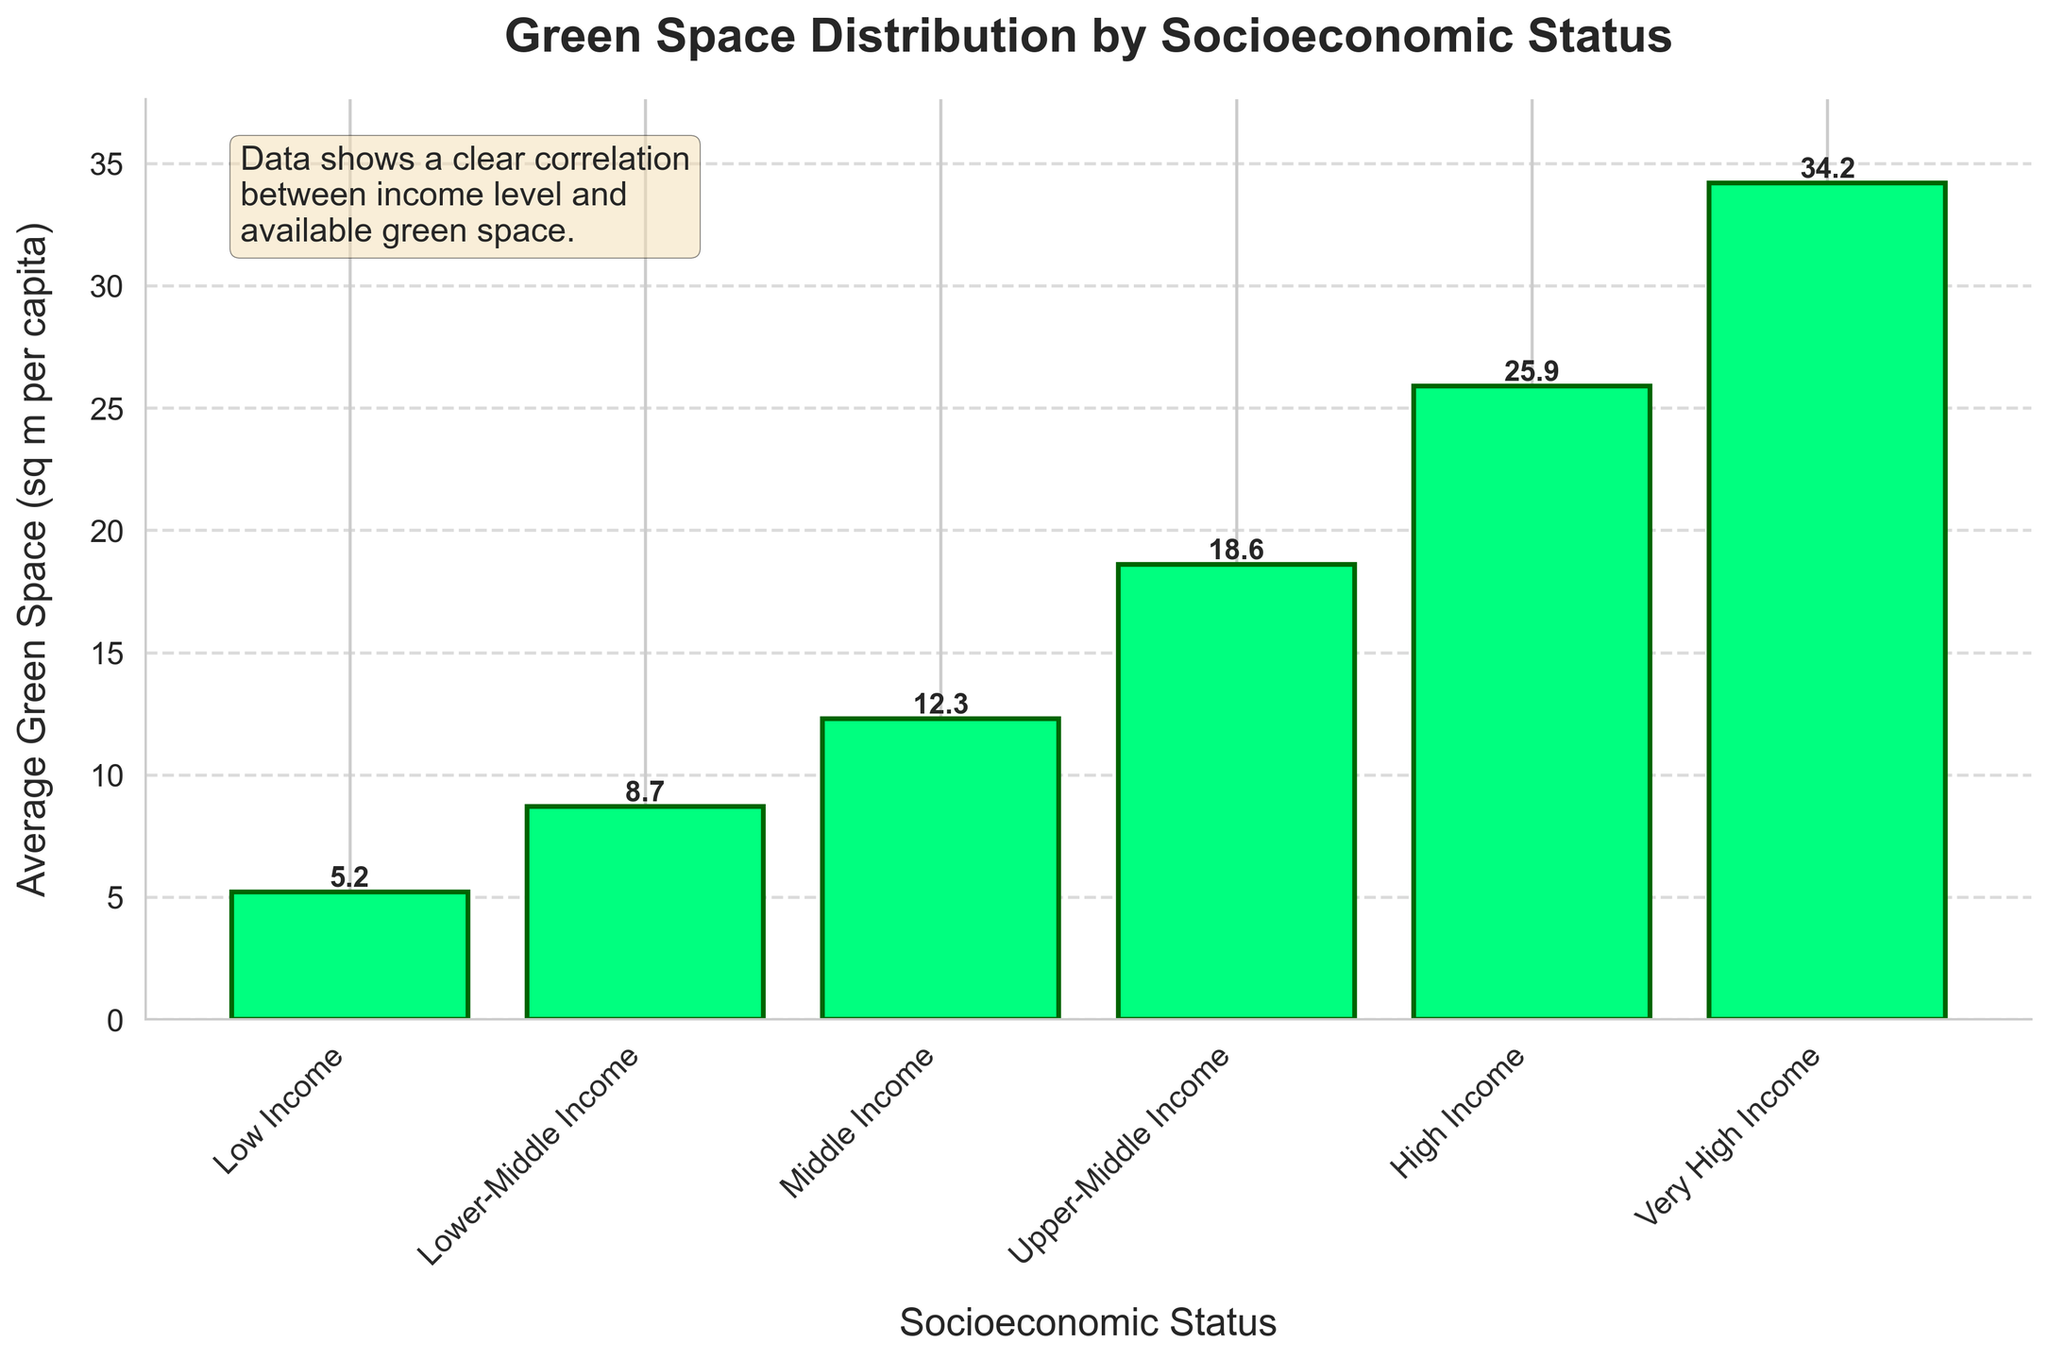What's the average green space per capita across all socioeconomic statuses? To find the average green space per capita, sum up all the values and divide by the number of socioeconomic statuses. The values are (5.2 + 8.7 + 12.3 + 18.6 + 25.9 + 34.2). Summing these gives 104.9. There are 6 statuses, so 104.9 / 6 = 17.5
Answer: 17.5 Which socioeconomic status has the least green space per capita? The lowest bar on the chart represents the socioeconomic status with the least green space. This is the "Low Income" category.
Answer: Low Income By how much is the green space per capita for High Income greater than that for Low Income? The green space per capita for High Income is 25.9, and for Low Income it is 5.2. The difference is 25.9 - 5.2 = 20.7
Answer: 20.7 What is the visual trend of green space distribution as socioeconomic status increases? By observing the heights of the bars, we can see that as the socioeconomic status increases from Low Income to Very High Income, the average green space per capita also increases.
Answer: Increases Which two socioeconomic statuses have the most similar green space per capita? Observing the bars, "Upper-Middle Income" and "High Income" have the closest values at 18.6 and 25.9 respectively, making their difference 25.9 - 18.6 = 7.3. This is the smallest difference observed between consecutive statuses.
Answer: Upper-Middle Income, High Income How much more green space per capita does the Very High Income category have compared to the Lower-Middle Income category? The green space per capita for the Very High Income category is 34.2, and for the Lower-Middle Income category it is 8.7. The difference is 34.2 - 8.7 = 25.5
Answer: 25.5 What logical relationship is illustrated by the text box in the figure? The text box mentions a correlation between income level and available green space, which aligns with the visual trend where higher socioeconomic statuses have more green space.
Answer: Correlation between income and green space What percentage increase in green space per capita is observed from Low Income to Very High Income categories? First, calculate the increase: 34.2 - 5.2 = 29. Then, (29 / 5.2) * 100 = 557.7%
Answer: 557.7% What is the ratio of green space per capita in Middle Income to Low Income categories? The green space per capita for Middle Income is 12.3, and for Low Income, it is 5.2. The ratio is 12.3 / 5.2 ≈ 2.37
Answer: 2.37 